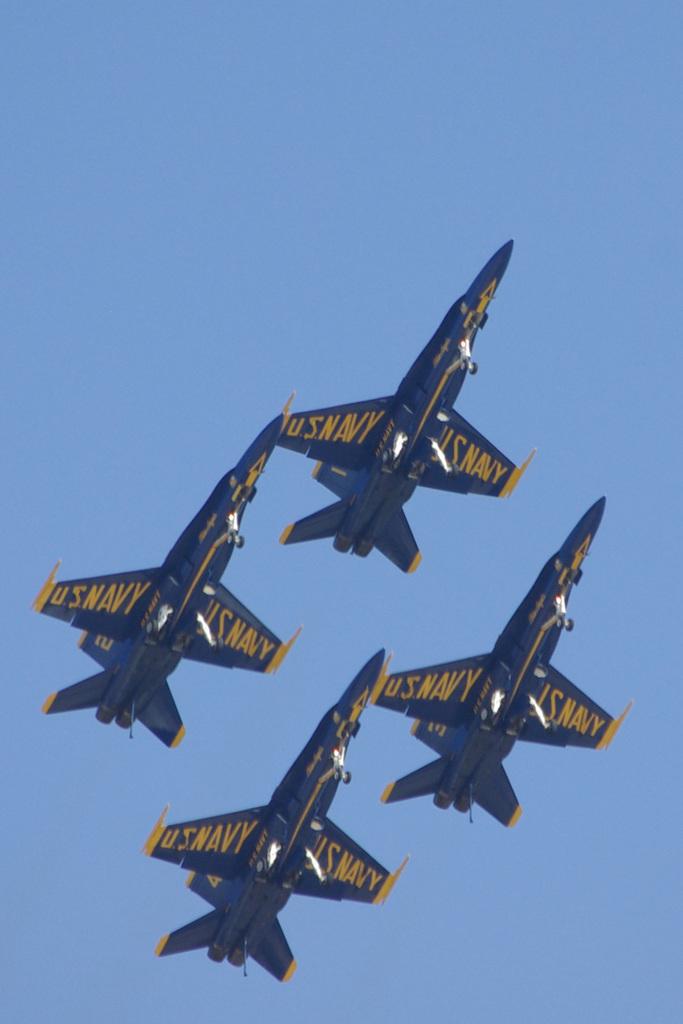What navy is on the planes?
Your answer should be very brief. Us navy. Who do the planes belong to?
Give a very brief answer. Us navy. 